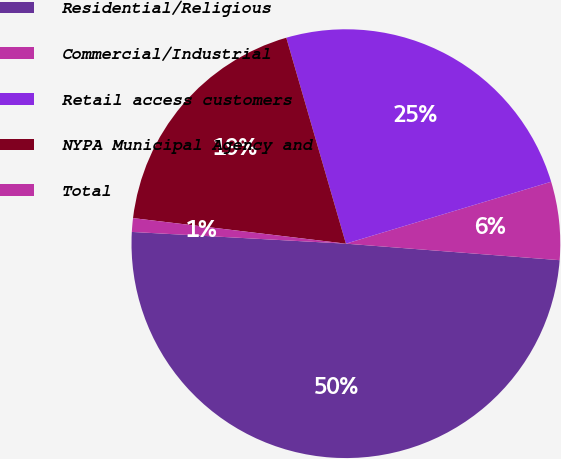Convert chart. <chart><loc_0><loc_0><loc_500><loc_500><pie_chart><fcel>Residential/Religious<fcel>Commercial/Industrial<fcel>Retail access customers<fcel>NYPA Municipal Agency and<fcel>Total<nl><fcel>49.64%<fcel>5.89%<fcel>24.82%<fcel>18.61%<fcel>1.03%<nl></chart> 